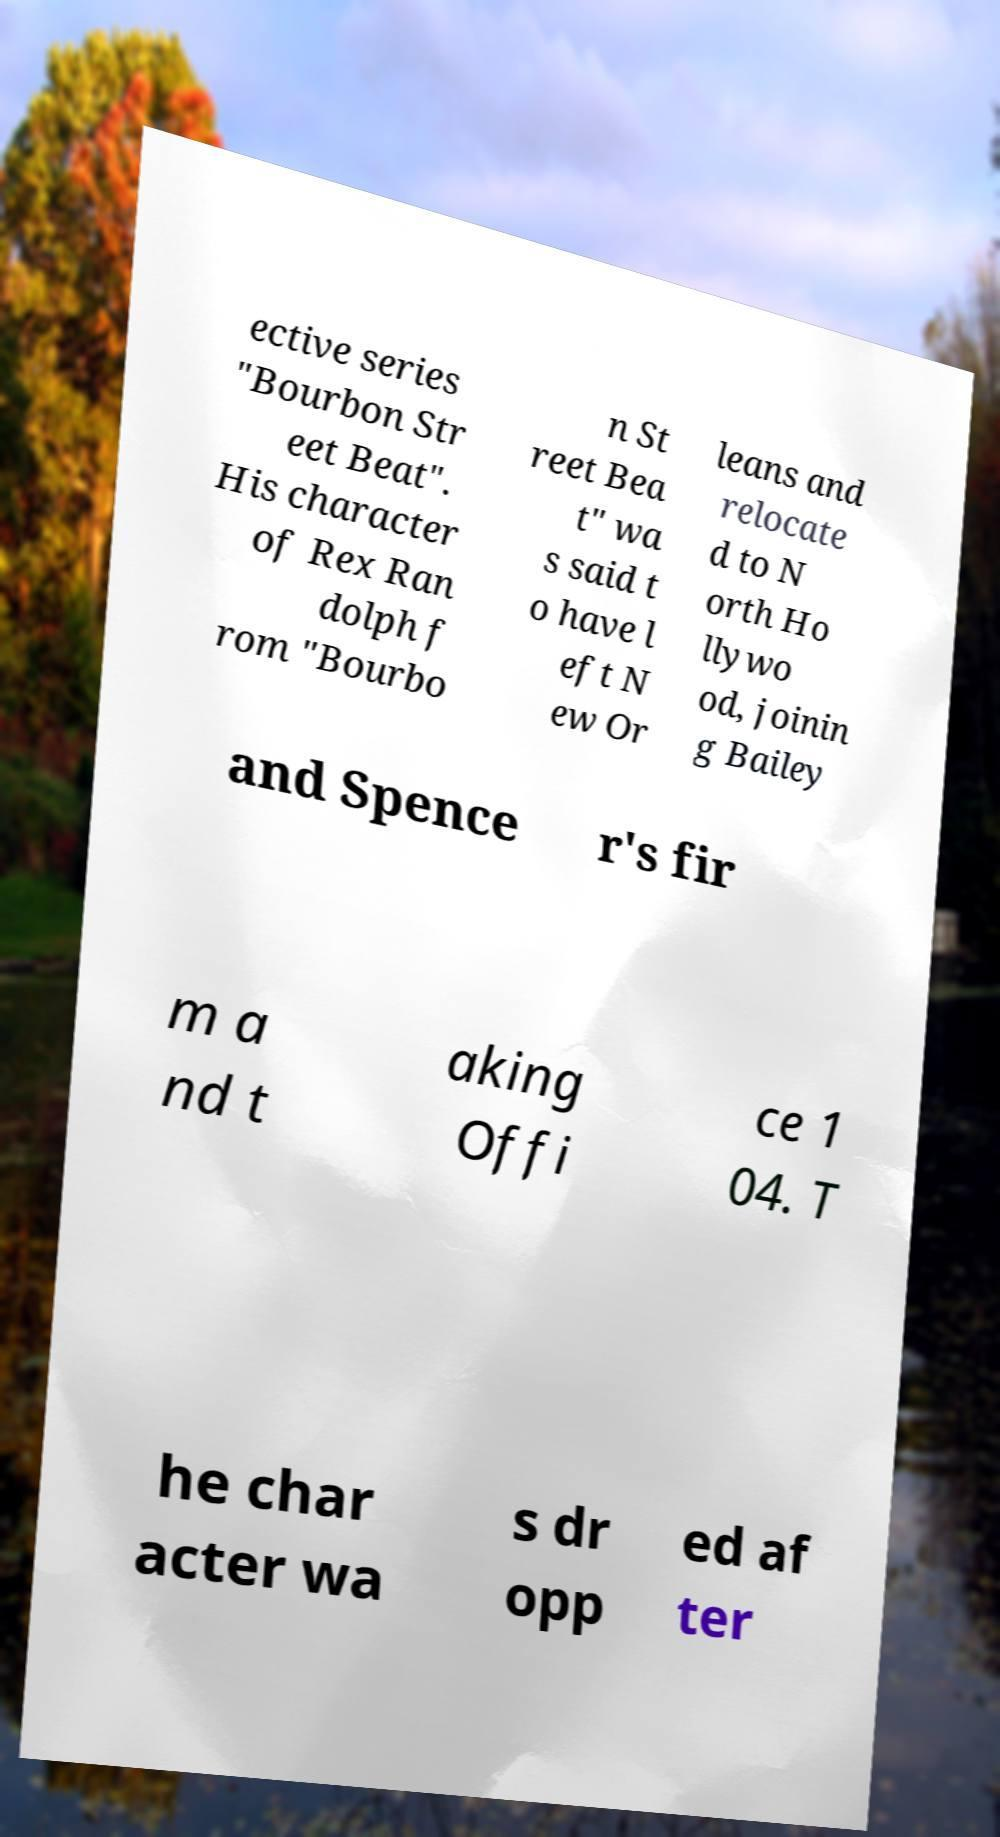What messages or text are displayed in this image? I need them in a readable, typed format. ective series "Bourbon Str eet Beat". His character of Rex Ran dolph f rom "Bourbo n St reet Bea t" wa s said t o have l eft N ew Or leans and relocate d to N orth Ho llywo od, joinin g Bailey and Spence r's fir m a nd t aking Offi ce 1 04. T he char acter wa s dr opp ed af ter 